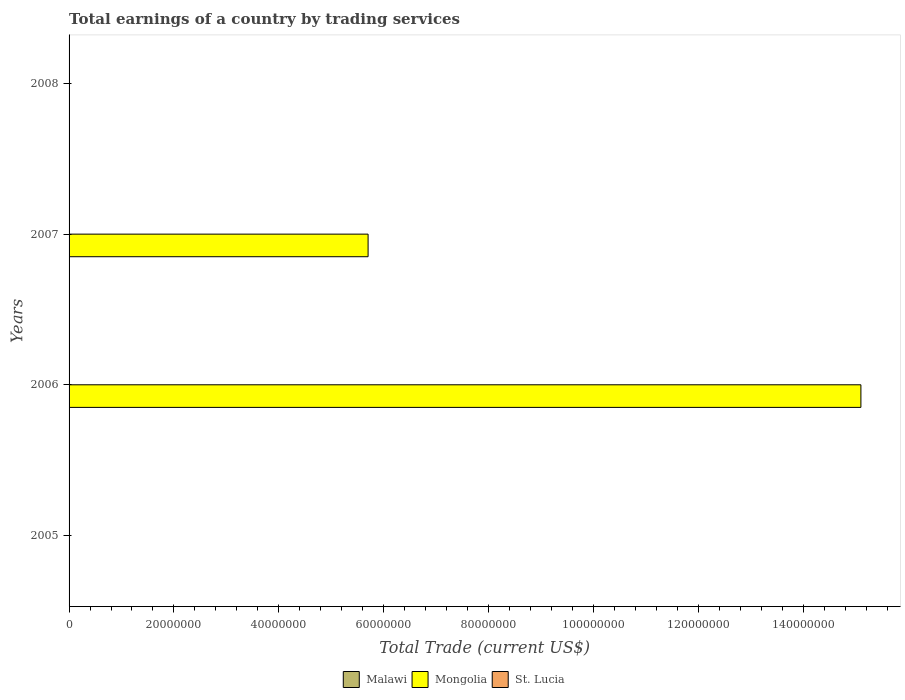Are the number of bars on each tick of the Y-axis equal?
Make the answer very short. No. How many bars are there on the 4th tick from the top?
Give a very brief answer. 0. What is the label of the 4th group of bars from the top?
Provide a short and direct response. 2005. In how many cases, is the number of bars for a given year not equal to the number of legend labels?
Ensure brevity in your answer.  4. What is the total earnings in Mongolia in 2008?
Your response must be concise. 0. Across all years, what is the minimum total earnings in St. Lucia?
Provide a short and direct response. 0. In which year was the total earnings in Mongolia maximum?
Make the answer very short. 2006. What is the total total earnings in Mongolia in the graph?
Your response must be concise. 2.08e+08. What is the difference between the total earnings in Mongolia in 2006 and that in 2007?
Your answer should be compact. 9.40e+07. What is the difference between the total earnings in Malawi in 2006 and the total earnings in Mongolia in 2008?
Provide a short and direct response. 0. In how many years, is the total earnings in Malawi greater than 104000000 US$?
Your answer should be compact. 0. In how many years, is the total earnings in Malawi greater than the average total earnings in Malawi taken over all years?
Offer a terse response. 0. Is it the case that in every year, the sum of the total earnings in St. Lucia and total earnings in Mongolia is greater than the total earnings in Malawi?
Offer a terse response. No. Are all the bars in the graph horizontal?
Your answer should be very brief. Yes. Does the graph contain grids?
Your response must be concise. No. What is the title of the graph?
Your answer should be very brief. Total earnings of a country by trading services. What is the label or title of the X-axis?
Provide a short and direct response. Total Trade (current US$). What is the label or title of the Y-axis?
Your answer should be very brief. Years. What is the Total Trade (current US$) in Malawi in 2006?
Make the answer very short. 0. What is the Total Trade (current US$) in Mongolia in 2006?
Your response must be concise. 1.51e+08. What is the Total Trade (current US$) of Mongolia in 2007?
Provide a succinct answer. 5.70e+07. What is the Total Trade (current US$) in Mongolia in 2008?
Make the answer very short. 0. What is the Total Trade (current US$) of St. Lucia in 2008?
Ensure brevity in your answer.  0. Across all years, what is the maximum Total Trade (current US$) in Mongolia?
Give a very brief answer. 1.51e+08. Across all years, what is the minimum Total Trade (current US$) in Mongolia?
Provide a short and direct response. 0. What is the total Total Trade (current US$) of Malawi in the graph?
Provide a succinct answer. 0. What is the total Total Trade (current US$) in Mongolia in the graph?
Provide a succinct answer. 2.08e+08. What is the difference between the Total Trade (current US$) of Mongolia in 2006 and that in 2007?
Offer a very short reply. 9.40e+07. What is the average Total Trade (current US$) in Mongolia per year?
Give a very brief answer. 5.20e+07. What is the ratio of the Total Trade (current US$) in Mongolia in 2006 to that in 2007?
Provide a succinct answer. 2.65. What is the difference between the highest and the lowest Total Trade (current US$) of Mongolia?
Offer a terse response. 1.51e+08. 